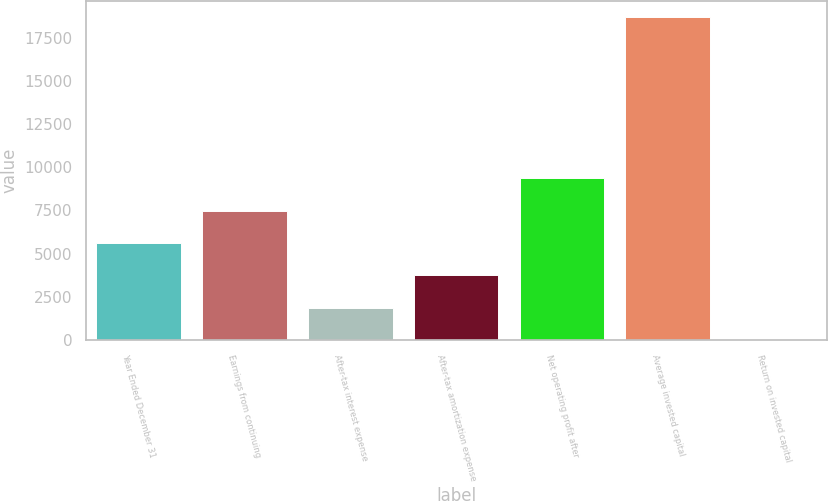<chart> <loc_0><loc_0><loc_500><loc_500><bar_chart><fcel>Year Ended December 31<fcel>Earnings from continuing<fcel>After-tax interest expense<fcel>After-tax amortization expense<fcel>Net operating profit after<fcel>Average invested capital<fcel>Return on invested capital<nl><fcel>5618.17<fcel>7485.86<fcel>1882.79<fcel>3750.48<fcel>9353.55<fcel>18692<fcel>15.1<nl></chart> 